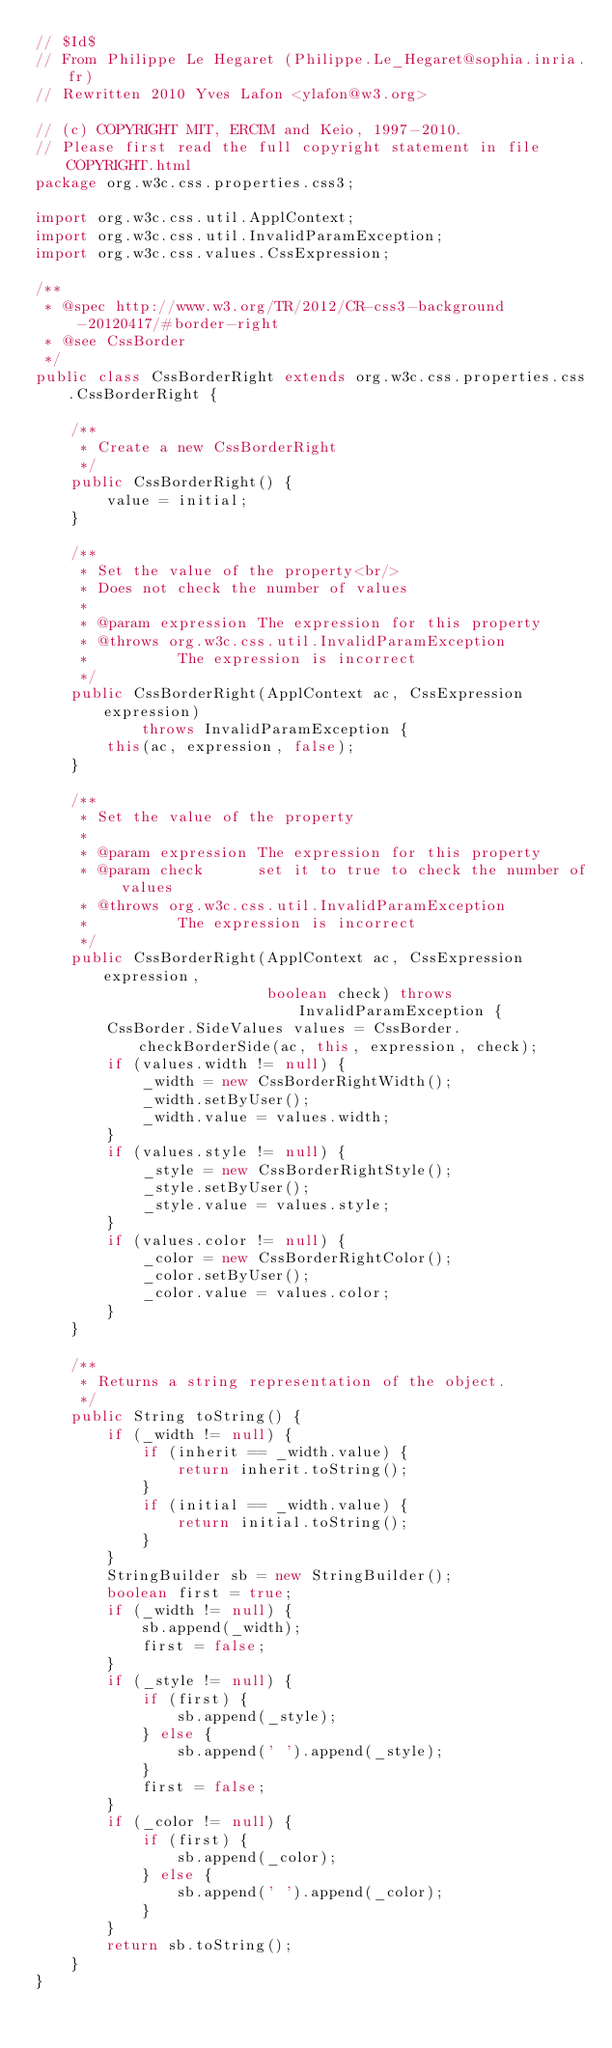Convert code to text. <code><loc_0><loc_0><loc_500><loc_500><_Java_>// $Id$
// From Philippe Le Hegaret (Philippe.Le_Hegaret@sophia.inria.fr)
// Rewritten 2010 Yves Lafon <ylafon@w3.org>

// (c) COPYRIGHT MIT, ERCIM and Keio, 1997-2010.
// Please first read the full copyright statement in file COPYRIGHT.html
package org.w3c.css.properties.css3;

import org.w3c.css.util.ApplContext;
import org.w3c.css.util.InvalidParamException;
import org.w3c.css.values.CssExpression;

/**
 * @spec http://www.w3.org/TR/2012/CR-css3-background-20120417/#border-right
 * @see CssBorder
 */
public class CssBorderRight extends org.w3c.css.properties.css.CssBorderRight {

    /**
     * Create a new CssBorderRight
     */
    public CssBorderRight() {
        value = initial;
    }

    /**
     * Set the value of the property<br/>
     * Does not check the number of values
     *
     * @param expression The expression for this property
     * @throws org.w3c.css.util.InvalidParamException
     *          The expression is incorrect
     */
    public CssBorderRight(ApplContext ac, CssExpression expression)
            throws InvalidParamException {
        this(ac, expression, false);
    }

    /**
     * Set the value of the property
     *
     * @param expression The expression for this property
     * @param check      set it to true to check the number of values
     * @throws org.w3c.css.util.InvalidParamException
     *          The expression is incorrect
     */
    public CssBorderRight(ApplContext ac, CssExpression expression,
                          boolean check) throws InvalidParamException {
        CssBorder.SideValues values = CssBorder.checkBorderSide(ac, this, expression, check);
        if (values.width != null) {
            _width = new CssBorderRightWidth();
            _width.setByUser();
            _width.value = values.width;
        }
        if (values.style != null) {
            _style = new CssBorderRightStyle();
            _style.setByUser();
            _style.value = values.style;
        }
        if (values.color != null) {
            _color = new CssBorderRightColor();
            _color.setByUser();
            _color.value = values.color;
        }
    }

    /**
     * Returns a string representation of the object.
     */
    public String toString() {
        if (_width != null) {
            if (inherit == _width.value) {
                return inherit.toString();
            }
            if (initial == _width.value) {
                return initial.toString();
            }
        }
        StringBuilder sb = new StringBuilder();
        boolean first = true;
        if (_width != null) {
            sb.append(_width);
            first = false;
        }
        if (_style != null) {
            if (first) {
                sb.append(_style);
            } else {
                sb.append(' ').append(_style);
            }
            first = false;
        }
        if (_color != null) {
            if (first) {
                sb.append(_color);
            } else {
                sb.append(' ').append(_color);
            }
        }
        return sb.toString();
    }
}
</code> 